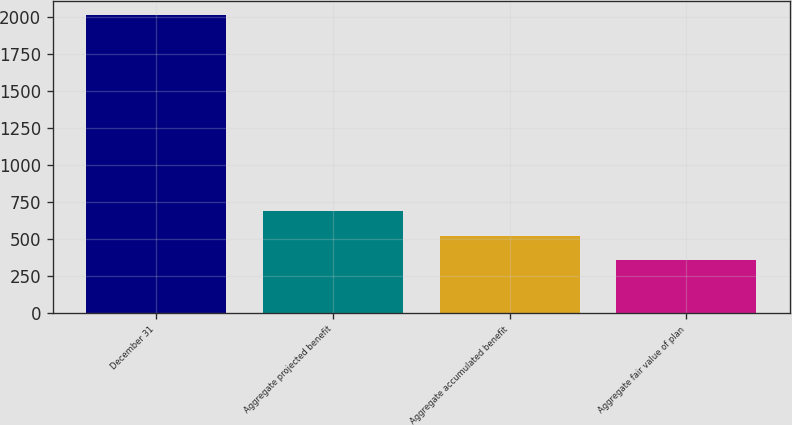Convert chart to OTSL. <chart><loc_0><loc_0><loc_500><loc_500><bar_chart><fcel>December 31<fcel>Aggregate projected benefit<fcel>Aggregate accumulated benefit<fcel>Aggregate fair value of plan<nl><fcel>2012<fcel>689.2<fcel>523.85<fcel>358.5<nl></chart> 